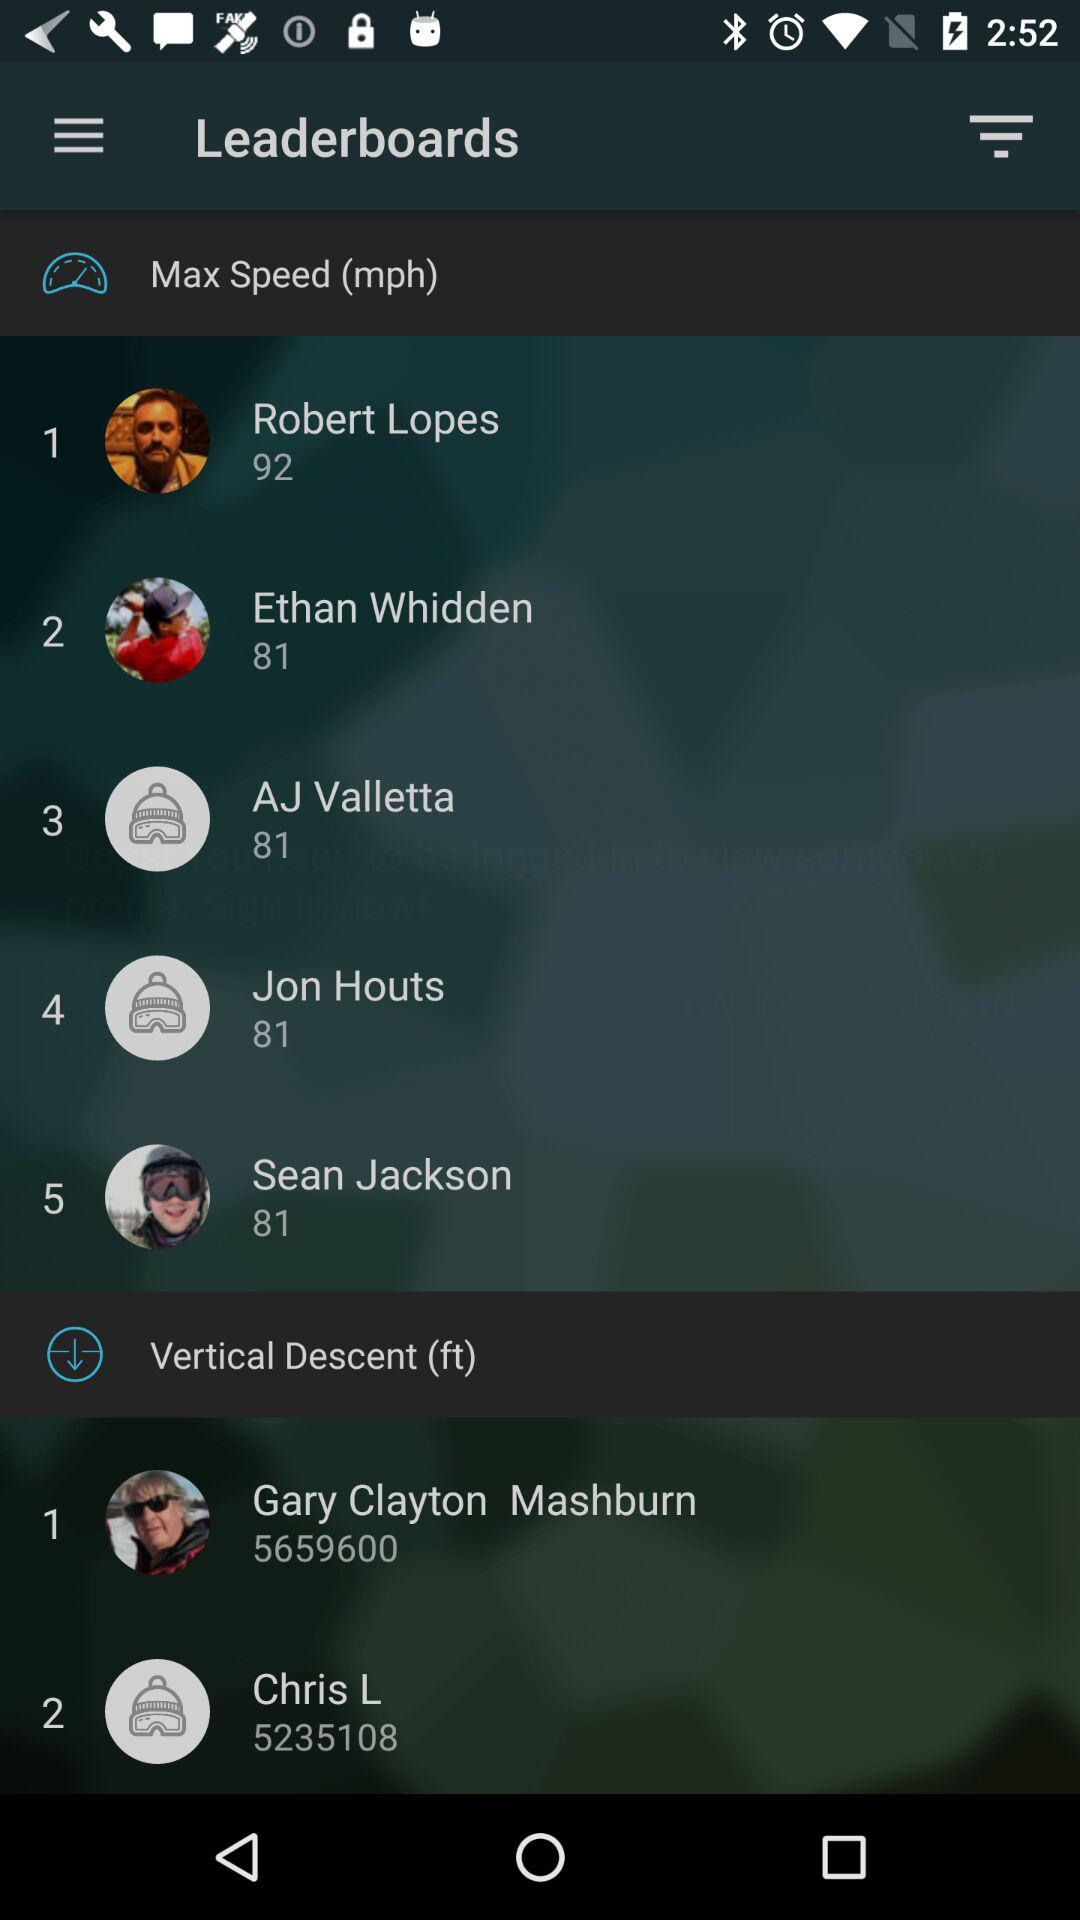How many leaders have a vertical descent greater than 5000ft?
Answer the question using a single word or phrase. 2 